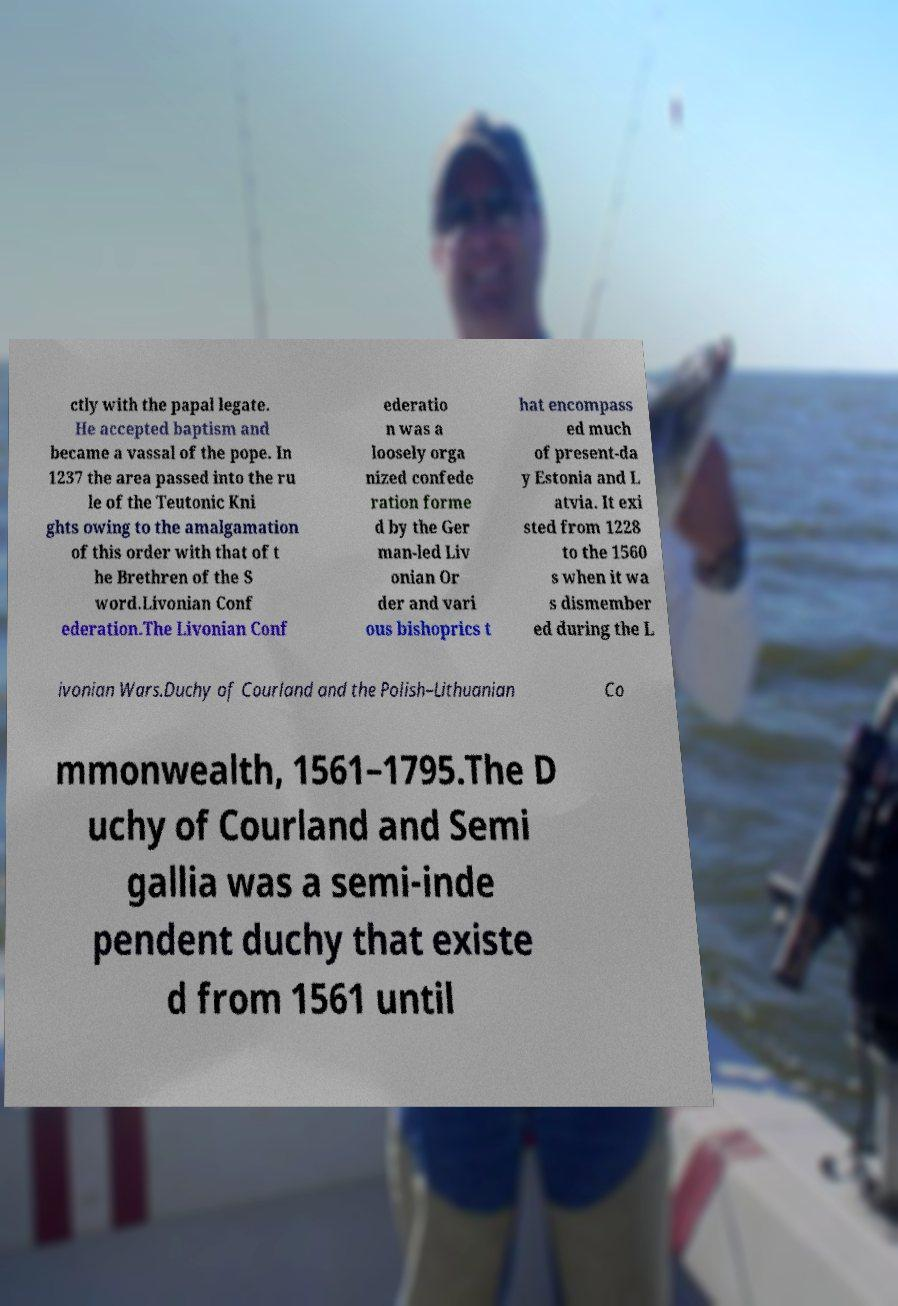What messages or text are displayed in this image? I need them in a readable, typed format. ctly with the papal legate. He accepted baptism and became a vassal of the pope. In 1237 the area passed into the ru le of the Teutonic Kni ghts owing to the amalgamation of this order with that of t he Brethren of the S word.Livonian Conf ederation.The Livonian Conf ederatio n was a loosely orga nized confede ration forme d by the Ger man-led Liv onian Or der and vari ous bishoprics t hat encompass ed much of present-da y Estonia and L atvia. It exi sted from 1228 to the 1560 s when it wa s dismember ed during the L ivonian Wars.Duchy of Courland and the Polish–Lithuanian Co mmonwealth, 1561–1795.The D uchy of Courland and Semi gallia was a semi-inde pendent duchy that existe d from 1561 until 